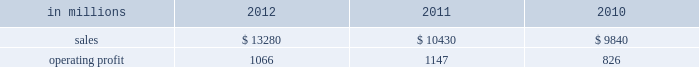( $ 125 million ) and higher maintenance outage costs ( $ 18 million ) .
Additionally , operating profits in 2012 include costs of $ 184 million associated with the acquisition and integration of temple-inland , mill divestiture costs of $ 91 million , costs associated with the restructuring of our european packaging busi- ness of $ 17 million and a $ 3 million gain for other items , while operating costs in 2011 included costs associated with signing an agreement to acquire temple-inland of $ 20 million and a gain of $ 7 million for other items .
Industrial packaging .
North american industr ia l packaging net sales were $ 11.6 billion in 2012 compared with $ 8.6 billion in 2011 and $ 8.4 billion in 2010 .
Operating profits in 2012 were $ 1.0 billion ( $ 1.3 billion exclud- ing costs associated with the acquisition and integration of temple-inland and mill divestiture costs ) compared with $ 1.1 billion ( both including and excluding costs associated with signing an agree- ment to acquire temple-inland ) in 2011 and $ 763 million ( $ 776 million excluding facility closure costs ) in 2010 .
Sales volumes for the legacy business were about flat in 2012 compared with 2011 .
Average sales price was lower mainly due to export containerboard sales prices which bottomed out in the first quarter but climbed steadily the rest of the year .
Input costs were lower for recycled fiber , wood and natural gas , but higher for starch .
Freight costs also increased .
Plan- ned maintenance downtime costs were higher than in 2011 .
Operating costs were higher largely due to routine inventory valuation adjustments operating profits in 2012 benefited from $ 235 million of temple-inland synergies .
Market-related downtime in 2012 was about 570000 tons compared with about 380000 tons in 2011 .
Operating profits in 2012 included $ 184 million of costs associated with the acquisition and integration of temple-inland and $ 91 million of costs associated with the divestiture of three containerboard mills .
Operating profits in 2011 included charges of $ 20 million for costs associated with the signing of the agreement to acquire temple- inland .
Looking ahead to 2013 , sales volumes in the first quarter compared with the fourth quarter of 2012 are expected to increase slightly for boxes due to a higher number of shipping days .
Average sales price realizations are expected to reflect the pass-through to box customers of a containerboard price increase implemented in 2012 .
Input costs are expected to be higher for recycled fiber , wood and starch .
Planned maintenance downtime costs are expected to be about $ 26 million higher with outages scheduled at eight mills compared with six mills in the 2012 fourth quarter .
Manufacturing operating costs are expected to be lower .
European industr ia l packaging net sales were $ 1.0 billion in 2012 compared with $ 1.1 billion in 2011 and $ 990 million in 2010 .
Operating profits in 2012 were $ 53 million ( $ 72 million excluding restructuring costs ) compared with $ 66 million ( $ 61 million excluding a gain for a bargain purchase price adjustment on an acquisition by our joint venture in turkey and costs associated with the closure of our etienne mill in france in 2009 ) in 2011 and $ 70 mil- lion ( $ 73 million before closure costs for our etienne mill ) in 2010 .
Sales volumes in 2012 were lower than in 2011 reflecting decreased demand for packaging in the industrial market due to a weaker overall economic environment in southern europe .
Demand for pack- aging in the agricultural markets was about flat year- over-year .
Average sales margins increased due to sales price increases implemented during 2011 and 2012 and lower board costs .
Other input costs were higher , primarily for energy and distribution .
Operat- ing profits in 2012 included a net gain of $ 10 million for an insurance settlement , partially offset by addi- tional operating costs , related to the earthquakes in northern italy in may which affected our san felice box plant .
Entering the first quarter of 2013 , sales volumes are expected to be stable reflecting a seasonal decrease in market demand in agricultural markets offset by an increase in industrial markets .
Average sales margins are expected to improve due to lower input costs for containerboard .
Other input costs should be about flat .
Operating costs are expected to be higher reflecting the absence of the earthquake insurance settlement that was received in the 2012 fourth quar- asian industr ia l packaging net sales and operating profits include the results of sca pack- aging since the acquisition on june 30 , 2010 , includ- ing the impact of incremental integration costs .
Net sales for the packaging operations were $ 400 million in 2012 compared with $ 410 million in 2011 and $ 255 million in 2010 .
Operating profits for the packaging operations were $ 2 million in 2012 compared with $ 2 million in 2011 and a loss of $ 7 million ( a loss of $ 4 million excluding facility closure costs ) in 2010 .
Operating profits were favorably impacted by higher average sales margins in 2012 compared with 2011 , but this benefit was offset by lower sales volumes and higher raw material costs and operating costs .
Looking ahead to the first quarter of 2013 , sales volumes and average sales margins are expected to decrease due to seasonality .
Net sales for the distribution operations were $ 260 million in 2012 compared with $ 285 million in 2011 and $ 240 million in 2010 .
Operating profits were $ 3 million in 2012 compared with $ 3 million in 2011 and about breakeven in 2010. .
What was the industrial packaging profit margin in 2012? 
Computations: (1066 / 13280)
Answer: 0.08027. 